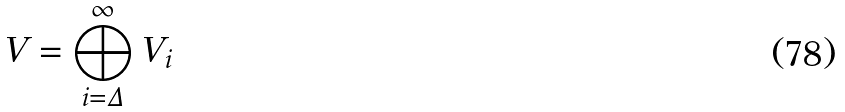<formula> <loc_0><loc_0><loc_500><loc_500>V & = \bigoplus _ { i = \Delta } ^ { \infty } V _ { i }</formula> 